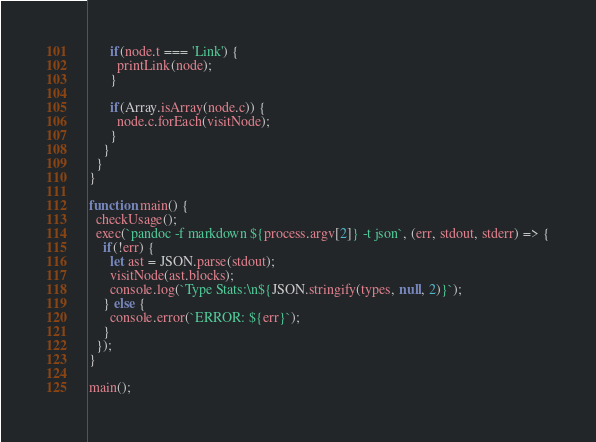<code> <loc_0><loc_0><loc_500><loc_500><_JavaScript_>      if(node.t === 'Link') {
        printLink(node);
      }

      if(Array.isArray(node.c)) {
        node.c.forEach(visitNode);
      }
    }
  }
}

function main() {
  checkUsage();
  exec(`pandoc -f markdown ${process.argv[2]} -t json`, (err, stdout, stderr) => {
    if(!err) {
      let ast = JSON.parse(stdout);
      visitNode(ast.blocks);
      console.log(`Type Stats:\n${JSON.stringify(types, null, 2)}`);
    } else {
      console.error(`ERROR: ${err}`);
    }
  });
}

main();
</code> 